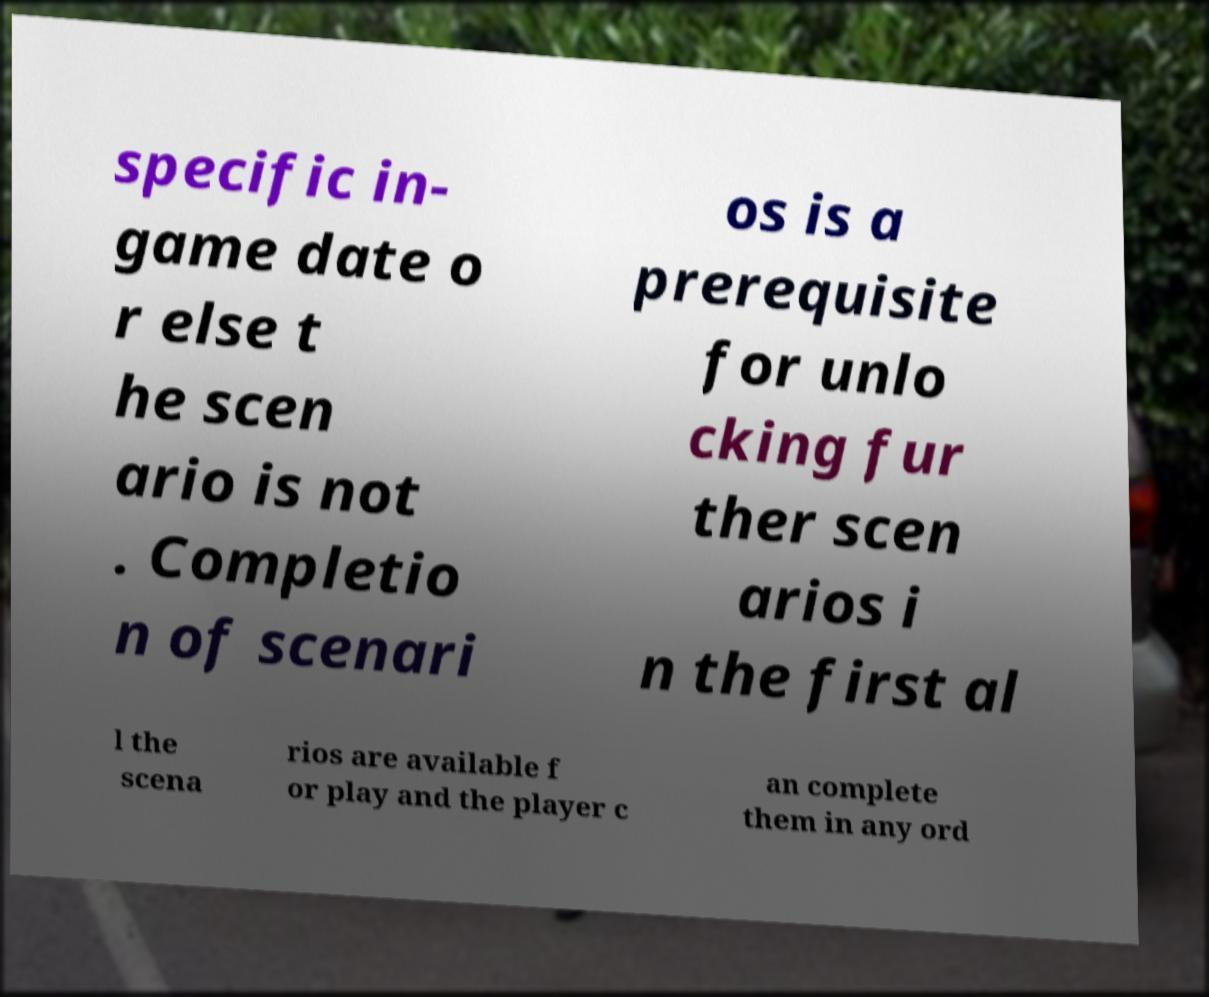For documentation purposes, I need the text within this image transcribed. Could you provide that? specific in- game date o r else t he scen ario is not . Completio n of scenari os is a prerequisite for unlo cking fur ther scen arios i n the first al l the scena rios are available f or play and the player c an complete them in any ord 